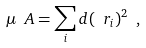<formula> <loc_0><loc_0><loc_500><loc_500>\mu _ { \ } A = \sum _ { i } d ( \ r _ { i } ) ^ { 2 } \ ,</formula> 